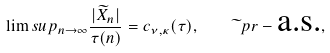Convert formula to latex. <formula><loc_0><loc_0><loc_500><loc_500>\lim s u p _ { n \to \infty } \frac { | \widetilde { X } _ { n } | } { \tau ( n ) } = c _ { \nu , \kappa } ( \tau ) , \quad \widetilde { \ } p r - \text {a.s.} ,</formula> 